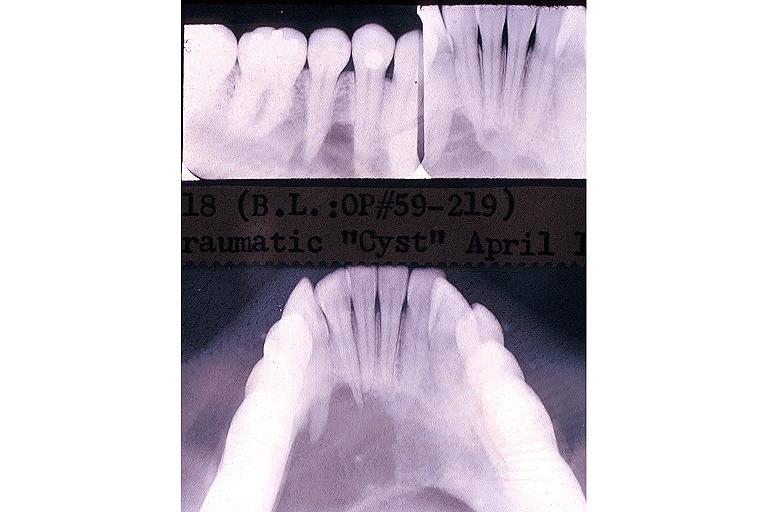what is present?
Answer the question using a single word or phrase. Oral 